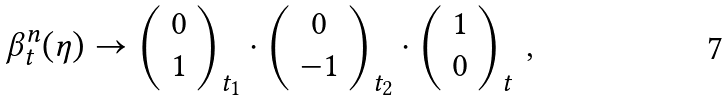<formula> <loc_0><loc_0><loc_500><loc_500>\beta _ { t } ^ { n } ( \eta ) \rightarrow \left ( \begin{array} { c } 0 \\ 1 \end{array} \right ) _ { t _ { 1 } } \cdot \left ( \begin{array} { c } 0 \\ - 1 \end{array} \right ) _ { t _ { 2 } } \cdot \left ( \begin{array} { c } 1 \\ 0 \end{array} \right ) _ { t } \, ,</formula> 